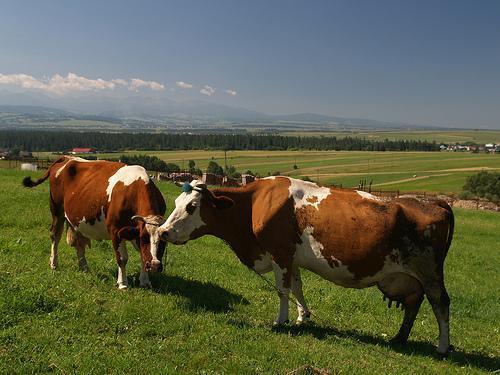How many cows are there?
Give a very brief answer. 2. 